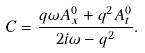Convert formula to latex. <formula><loc_0><loc_0><loc_500><loc_500>C = \frac { q \omega A ^ { 0 } _ { x } + q ^ { 2 } A ^ { 0 } _ { t } } { 2 i \omega - q ^ { 2 } } .</formula> 